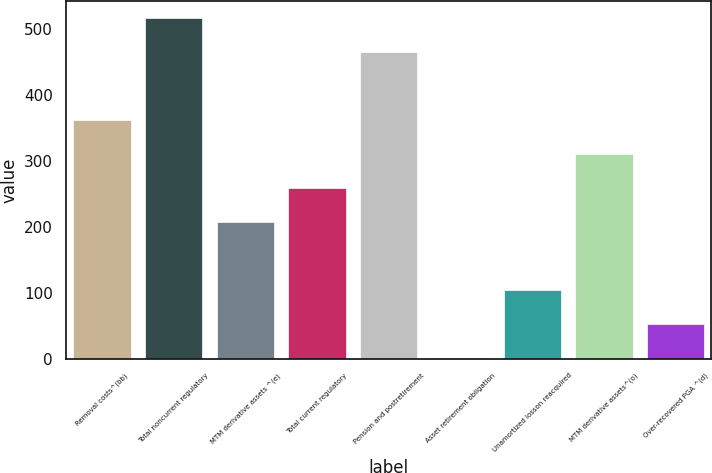Convert chart. <chart><loc_0><loc_0><loc_500><loc_500><bar_chart><fcel>Removal costs^(bb)<fcel>Total noncurrent regulatory<fcel>MTM derivative assets ^(e)<fcel>Total current regulatory<fcel>Pension and postretirement<fcel>Asset retirement obligation<fcel>Unamortized losson reacquired<fcel>MTM derivative assets^(o)<fcel>Over-recovered PGA ^(d)<nl><fcel>362.5<fcel>517<fcel>208<fcel>259.5<fcel>465.5<fcel>2<fcel>105<fcel>311<fcel>53.5<nl></chart> 